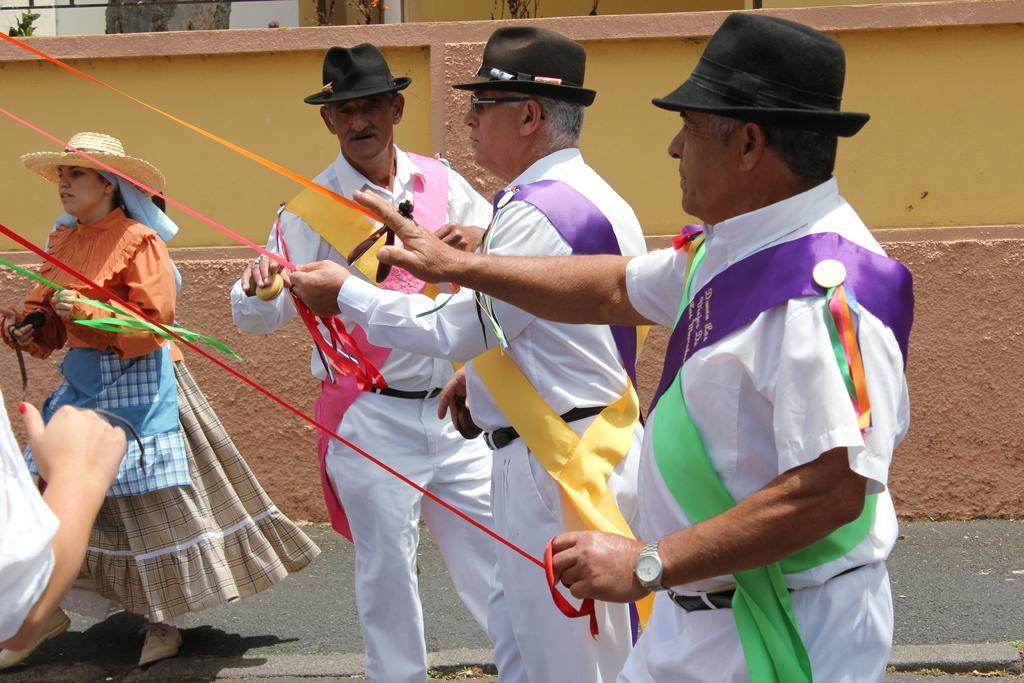In one or two sentences, can you explain what this image depicts? Here men and women are standing, this is wall. 